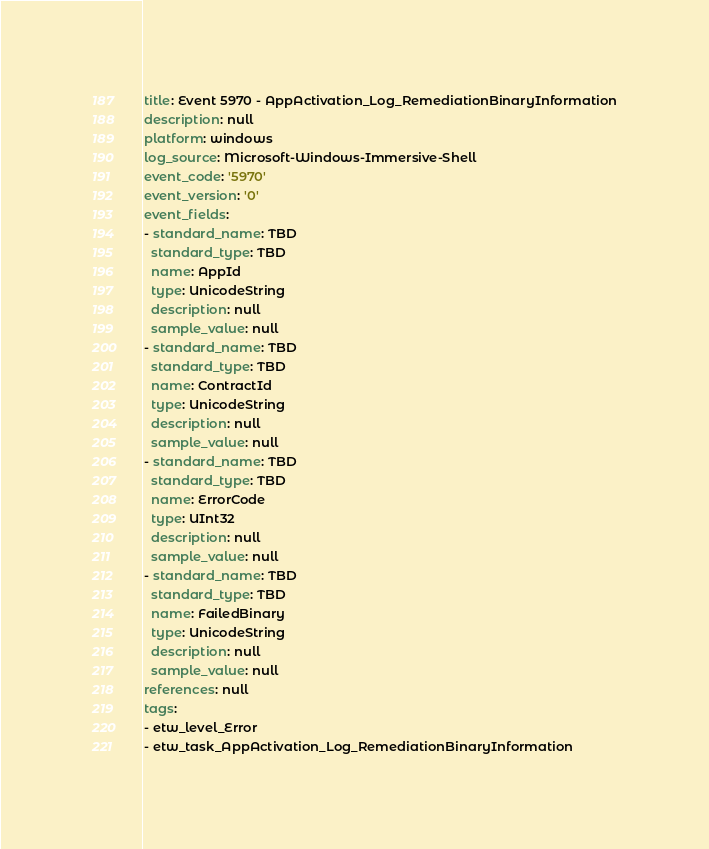<code> <loc_0><loc_0><loc_500><loc_500><_YAML_>title: Event 5970 - AppActivation_Log_RemediationBinaryInformation
description: null
platform: windows
log_source: Microsoft-Windows-Immersive-Shell
event_code: '5970'
event_version: '0'
event_fields:
- standard_name: TBD
  standard_type: TBD
  name: AppId
  type: UnicodeString
  description: null
  sample_value: null
- standard_name: TBD
  standard_type: TBD
  name: ContractId
  type: UnicodeString
  description: null
  sample_value: null
- standard_name: TBD
  standard_type: TBD
  name: ErrorCode
  type: UInt32
  description: null
  sample_value: null
- standard_name: TBD
  standard_type: TBD
  name: FailedBinary
  type: UnicodeString
  description: null
  sample_value: null
references: null
tags:
- etw_level_Error
- etw_task_AppActivation_Log_RemediationBinaryInformation
</code> 